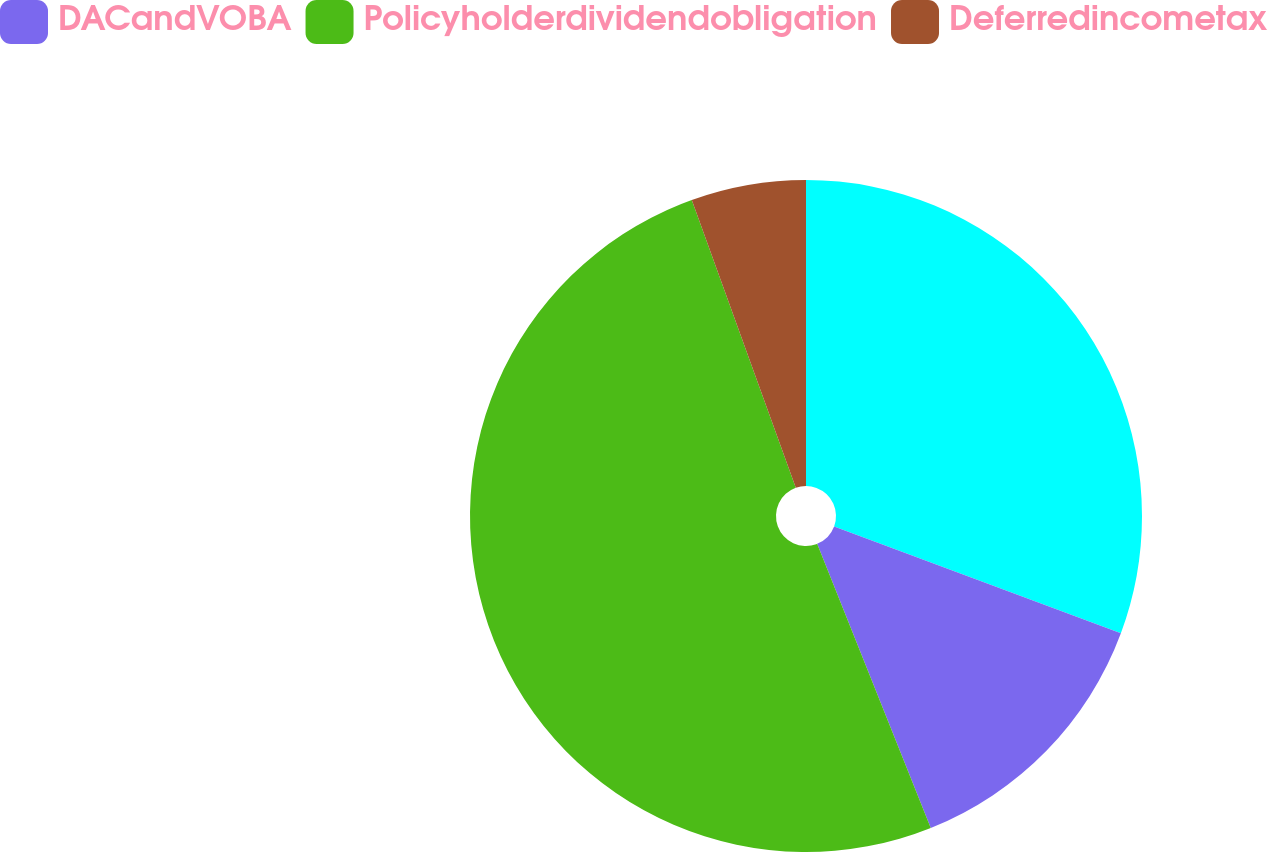<chart> <loc_0><loc_0><loc_500><loc_500><pie_chart><ecel><fcel>DACandVOBA<fcel>Policyholderdividendobligation<fcel>Deferredincometax<nl><fcel>30.67%<fcel>13.27%<fcel>50.53%<fcel>5.52%<nl></chart> 